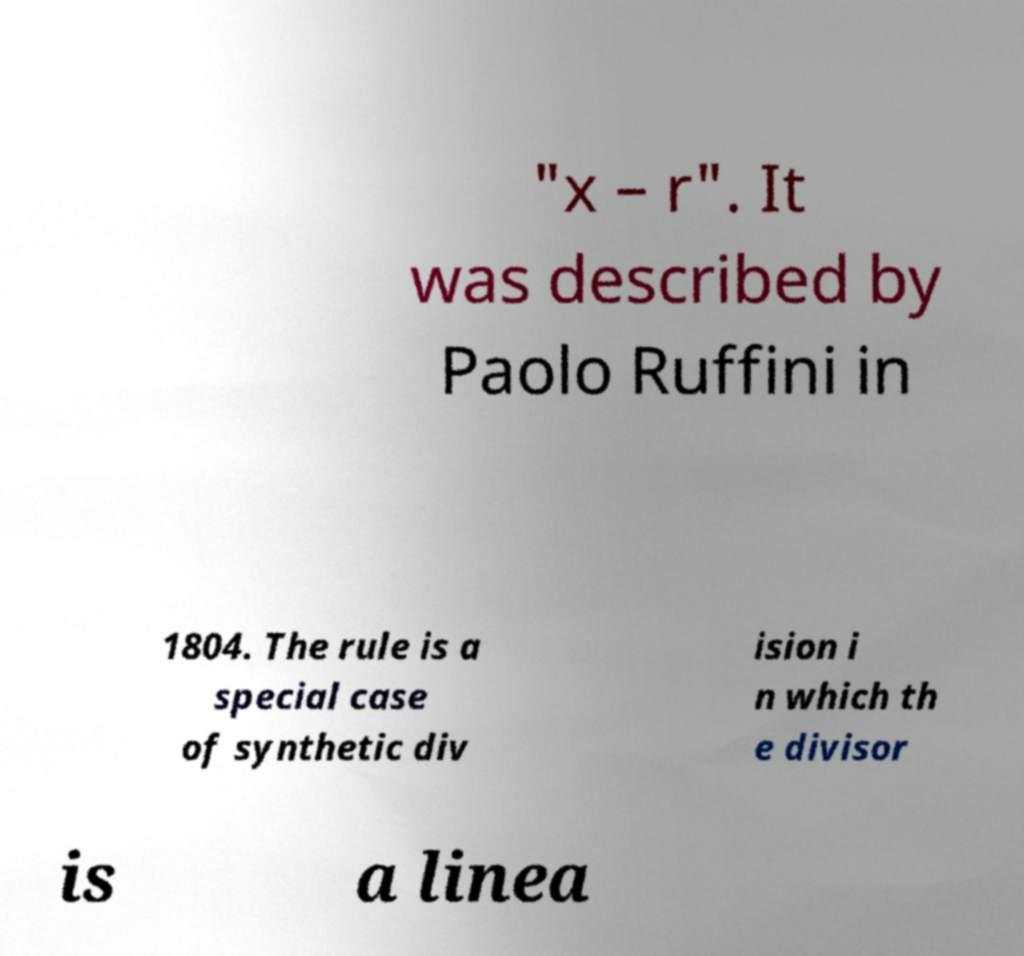Can you accurately transcribe the text from the provided image for me? "x – r". It was described by Paolo Ruffini in 1804. The rule is a special case of synthetic div ision i n which th e divisor is a linea 